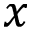Convert formula to latex. <formula><loc_0><loc_0><loc_500><loc_500>x</formula> 